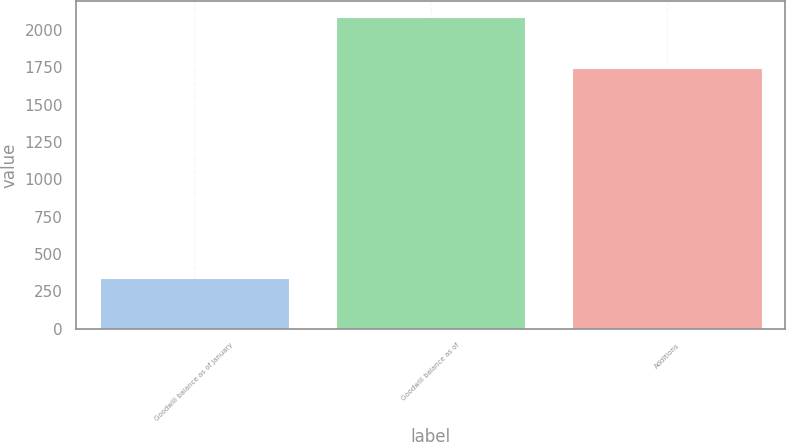Convert chart. <chart><loc_0><loc_0><loc_500><loc_500><bar_chart><fcel>Goodwill balance as of January<fcel>Goodwill balance as of<fcel>Additions<nl><fcel>339.6<fcel>2088<fcel>1748.4<nl></chart> 